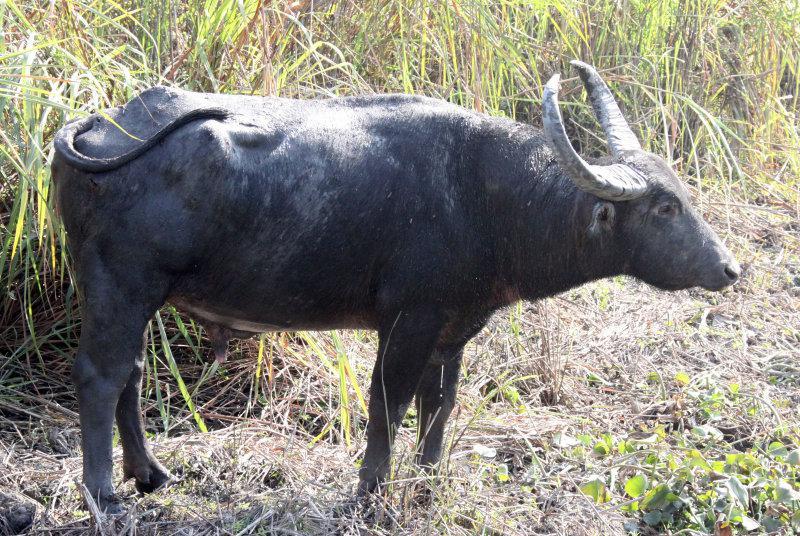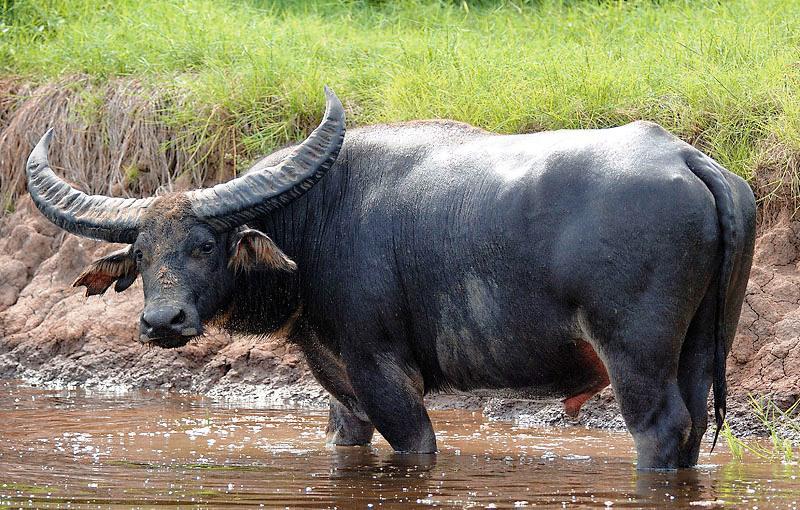The first image is the image on the left, the second image is the image on the right. Analyze the images presented: Is the assertion "An image shows exactly two water buffalo standing in profile." valid? Answer yes or no. No. The first image is the image on the left, the second image is the image on the right. Analyze the images presented: Is the assertion "The animals in the image on the left are near an area of water." valid? Answer yes or no. No. The first image is the image on the left, the second image is the image on the right. For the images displayed, is the sentence "There are exactly two animals in the image on the left." factually correct? Answer yes or no. No. The first image is the image on the left, the second image is the image on the right. For the images displayed, is the sentence "Two cows are in the picture on the left." factually correct? Answer yes or no. No. 